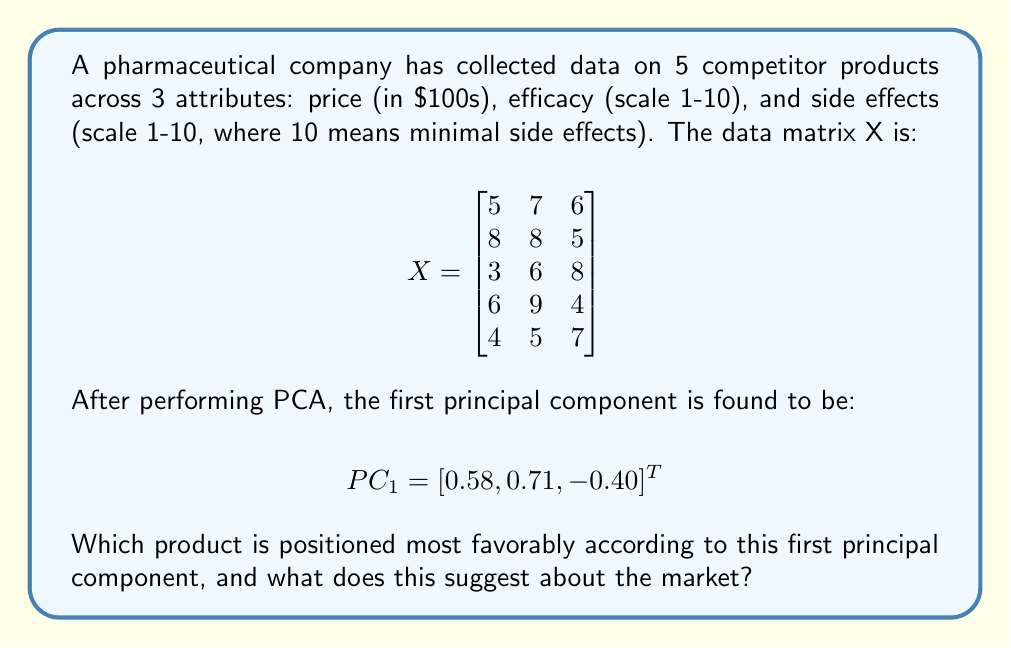Give your solution to this math problem. To solve this problem, we need to follow these steps:

1) Understand the meaning of the first principal component:
   The first principal component (PC1) represents the direction of maximum variance in the data. In this case:
   - 0.58 for price suggests higher prices contribute positively
   - 0.71 for efficacy indicates higher efficacy is strongly favorable
   - -0.40 for side effects means fewer side effects (higher values) contribute negatively

2) Project each product onto PC1:
   We do this by multiplying each row of X by PC1:

   Product 1: $5(0.58) + 7(0.71) + 6(-0.40) = 5.77$
   Product 2: $8(0.58) + 8(0.71) + 5(-0.40) = 8.46$
   Product 3: $3(0.58) + 6(0.71) + 8(-0.40) = 4.98$
   Product 4: $6(0.58) + 9(0.71) + 4(-0.40) = 8.91$
   Product 5: $4(0.58) + 5(0.71) + 7(-0.40) = 4.38$

3) Identify the highest score:
   Product 4 has the highest score of 8.91.

4) Interpret the result:
   Product 4 is positioned most favorably according to PC1. This product has high price ($600) and very high efficacy (9/10), which aligns well with the positive coefficients for these attributes in PC1. Its lower side effect score (4/10) is less impactful due to the smaller magnitude of the negative coefficient for side effects.

5) Market interpretation:
   This suggests that the market values efficacy most highly, followed by price (with higher prices seen as favorable, possibly indicating a premium market), while minimizing side effects is relatively less important.
Answer: Product 4; market values high efficacy and premium pricing over minimal side effects. 